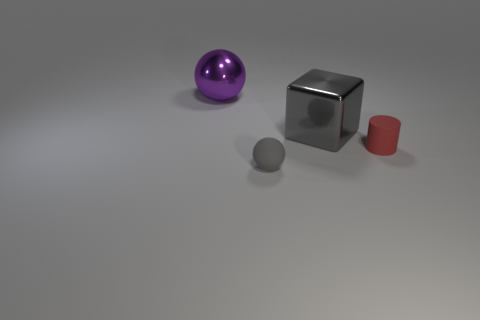Subtract all blue cubes. Subtract all red cylinders. How many cubes are left? 1 Add 2 tiny red rubber cylinders. How many objects exist? 6 Subtract all cubes. How many objects are left? 3 Subtract 1 gray balls. How many objects are left? 3 Subtract all gray metallic things. Subtract all purple metallic balls. How many objects are left? 2 Add 4 purple metallic balls. How many purple metallic balls are left? 5 Add 4 gray cubes. How many gray cubes exist? 5 